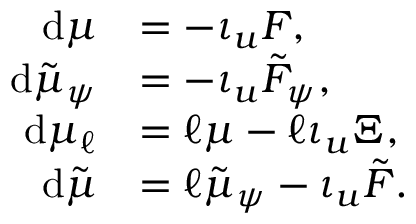<formula> <loc_0><loc_0><loc_500><loc_500>\begin{array} { r l } { d \mu } & { = - \iota _ { u } F , } \\ { d \tilde { \mu } _ { \psi } } & { = - \iota _ { u } \tilde { F } _ { \psi } , } \\ { d \mu _ { \ell } } & { = \ell \mu - \ell \iota _ { u } \Xi , } \\ { d \tilde { \mu } } & { = \ell \tilde { \mu } _ { \psi } - \iota _ { u } \tilde { F } . } \end{array}</formula> 